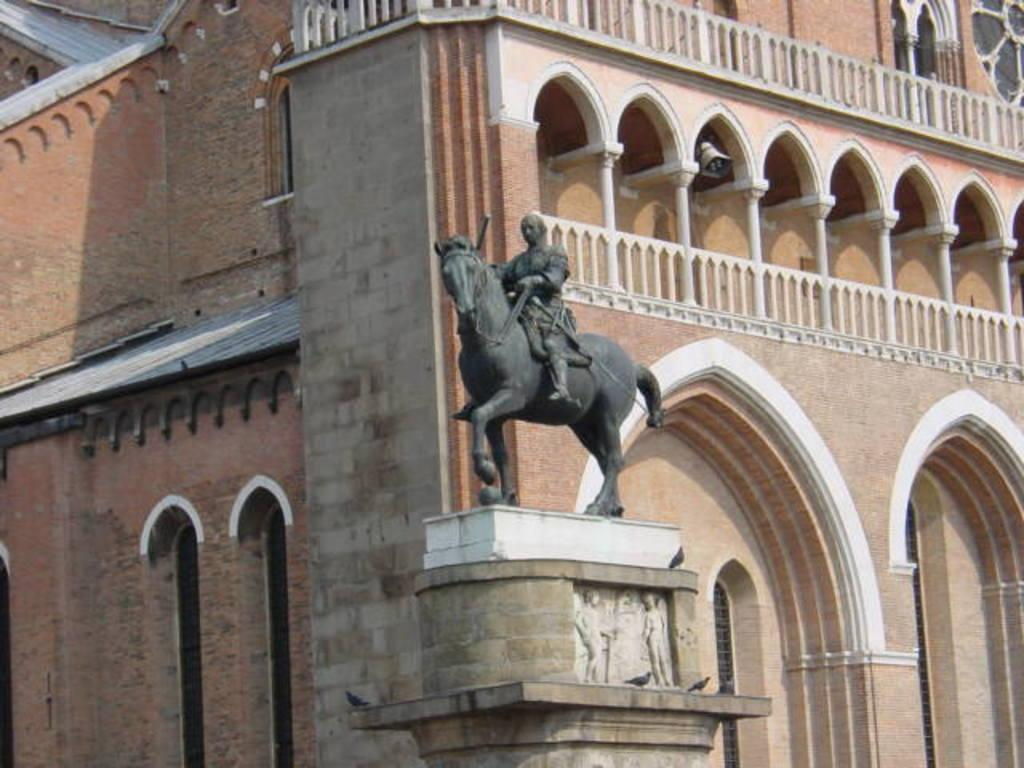What type of structure is visible in the image? There is a building in the image. What is located in front of the building? There is a pillar in front of the building. What is on top of the pillar? There is a statue of a person on the pillar. What is the person in the statue doing? The person in the statue is sitting on a horse. What type of ship can be seen sailing in the background of the image? There is no ship visible in the image; it only features a building, a pillar, and a statue. 